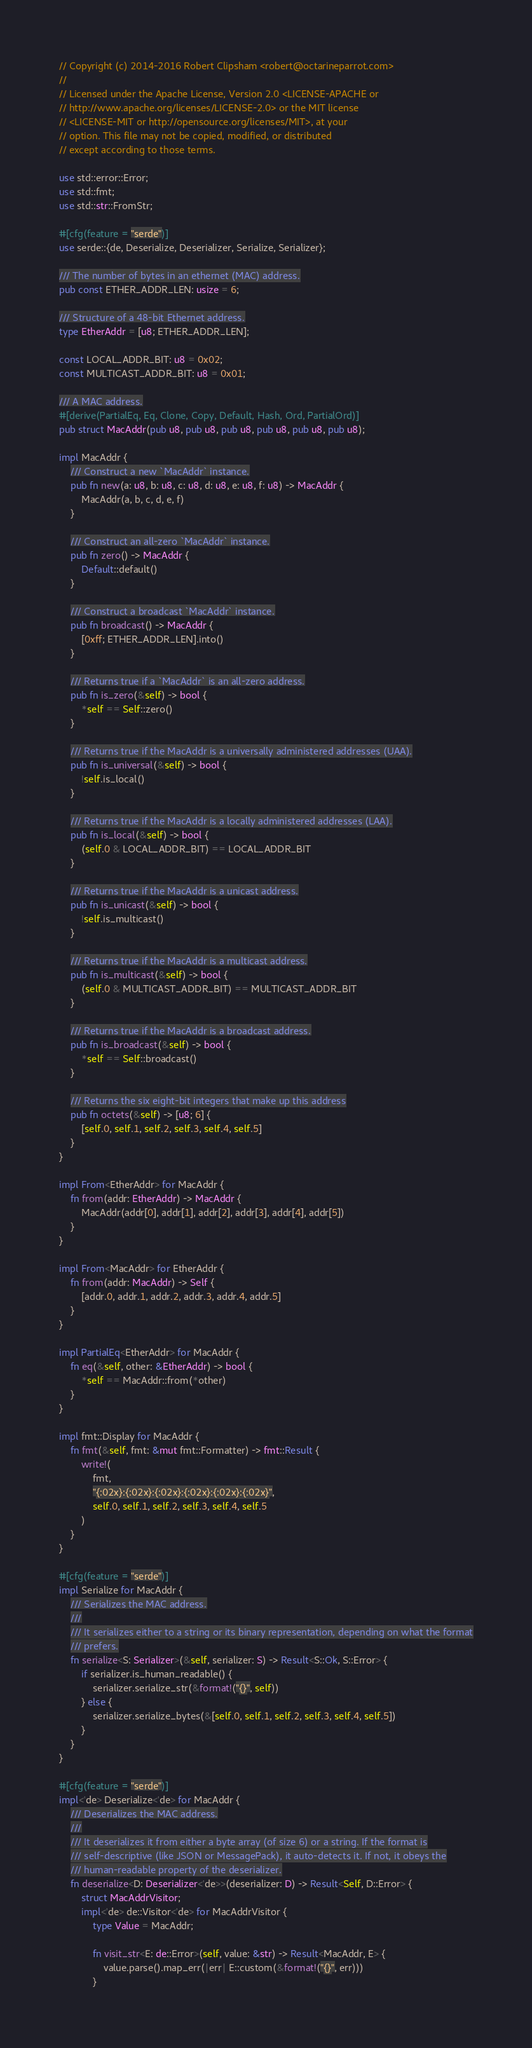Convert code to text. <code><loc_0><loc_0><loc_500><loc_500><_Rust_>// Copyright (c) 2014-2016 Robert Clipsham <robert@octarineparrot.com>
//
// Licensed under the Apache License, Version 2.0 <LICENSE-APACHE or
// http://www.apache.org/licenses/LICENSE-2.0> or the MIT license
// <LICENSE-MIT or http://opensource.org/licenses/MIT>, at your
// option. This file may not be copied, modified, or distributed
// except according to those terms.

use std::error::Error;
use std::fmt;
use std::str::FromStr;

#[cfg(feature = "serde")]
use serde::{de, Deserialize, Deserializer, Serialize, Serializer};

/// The number of bytes in an ethernet (MAC) address.
pub const ETHER_ADDR_LEN: usize = 6;

/// Structure of a 48-bit Ethernet address.
type EtherAddr = [u8; ETHER_ADDR_LEN];

const LOCAL_ADDR_BIT: u8 = 0x02;
const MULTICAST_ADDR_BIT: u8 = 0x01;

/// A MAC address.
#[derive(PartialEq, Eq, Clone, Copy, Default, Hash, Ord, PartialOrd)]
pub struct MacAddr(pub u8, pub u8, pub u8, pub u8, pub u8, pub u8);

impl MacAddr {
    /// Construct a new `MacAddr` instance.
    pub fn new(a: u8, b: u8, c: u8, d: u8, e: u8, f: u8) -> MacAddr {
        MacAddr(a, b, c, d, e, f)
    }

    /// Construct an all-zero `MacAddr` instance.
    pub fn zero() -> MacAddr {
        Default::default()
    }

    /// Construct a broadcast `MacAddr` instance.
    pub fn broadcast() -> MacAddr {
        [0xff; ETHER_ADDR_LEN].into()
    }

    /// Returns true if a `MacAddr` is an all-zero address.
    pub fn is_zero(&self) -> bool {
        *self == Self::zero()
    }

    /// Returns true if the MacAddr is a universally administered addresses (UAA).
    pub fn is_universal(&self) -> bool {
        !self.is_local()
    }

    /// Returns true if the MacAddr is a locally administered addresses (LAA).
    pub fn is_local(&self) -> bool {
        (self.0 & LOCAL_ADDR_BIT) == LOCAL_ADDR_BIT
    }

    /// Returns true if the MacAddr is a unicast address.
    pub fn is_unicast(&self) -> bool {
        !self.is_multicast()
    }

    /// Returns true if the MacAddr is a multicast address.
    pub fn is_multicast(&self) -> bool {
        (self.0 & MULTICAST_ADDR_BIT) == MULTICAST_ADDR_BIT
    }

    /// Returns true if the MacAddr is a broadcast address.
    pub fn is_broadcast(&self) -> bool {
        *self == Self::broadcast()
    }

    /// Returns the six eight-bit integers that make up this address
    pub fn octets(&self) -> [u8; 6] {
        [self.0, self.1, self.2, self.3, self.4, self.5]
    }
}

impl From<EtherAddr> for MacAddr {
    fn from(addr: EtherAddr) -> MacAddr {
        MacAddr(addr[0], addr[1], addr[2], addr[3], addr[4], addr[5])
    }
}

impl From<MacAddr> for EtherAddr {
    fn from(addr: MacAddr) -> Self {
        [addr.0, addr.1, addr.2, addr.3, addr.4, addr.5]
    }
}

impl PartialEq<EtherAddr> for MacAddr {
    fn eq(&self, other: &EtherAddr) -> bool {
        *self == MacAddr::from(*other)
    }
}

impl fmt::Display for MacAddr {
    fn fmt(&self, fmt: &mut fmt::Formatter) -> fmt::Result {
        write!(
            fmt,
            "{:02x}:{:02x}:{:02x}:{:02x}:{:02x}:{:02x}",
            self.0, self.1, self.2, self.3, self.4, self.5
        )
    }
}

#[cfg(feature = "serde")]
impl Serialize for MacAddr {
    /// Serializes the MAC address.
    ///
    /// It serializes either to a string or its binary representation, depending on what the format
    /// prefers.
    fn serialize<S: Serializer>(&self, serializer: S) -> Result<S::Ok, S::Error> {
        if serializer.is_human_readable() {
            serializer.serialize_str(&format!("{}", self))
        } else {
            serializer.serialize_bytes(&[self.0, self.1, self.2, self.3, self.4, self.5])
        }
    }
}

#[cfg(feature = "serde")]
impl<'de> Deserialize<'de> for MacAddr {
    /// Deserializes the MAC address.
    ///
    /// It deserializes it from either a byte array (of size 6) or a string. If the format is
    /// self-descriptive (like JSON or MessagePack), it auto-detects it. If not, it obeys the
    /// human-readable property of the deserializer.
    fn deserialize<D: Deserializer<'de>>(deserializer: D) -> Result<Self, D::Error> {
        struct MacAddrVisitor;
        impl<'de> de::Visitor<'de> for MacAddrVisitor {
            type Value = MacAddr;

            fn visit_str<E: de::Error>(self, value: &str) -> Result<MacAddr, E> {
                value.parse().map_err(|err| E::custom(&format!("{}", err)))
            }
</code> 